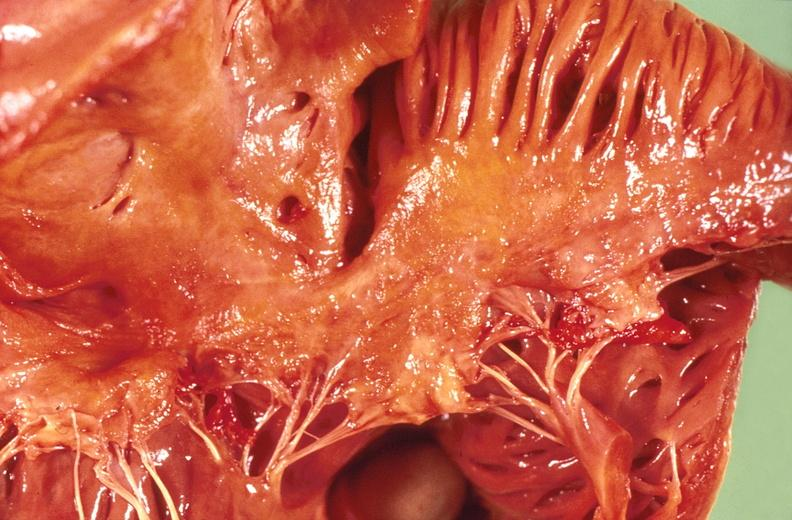does this image show amyloidosis?
Answer the question using a single word or phrase. Yes 